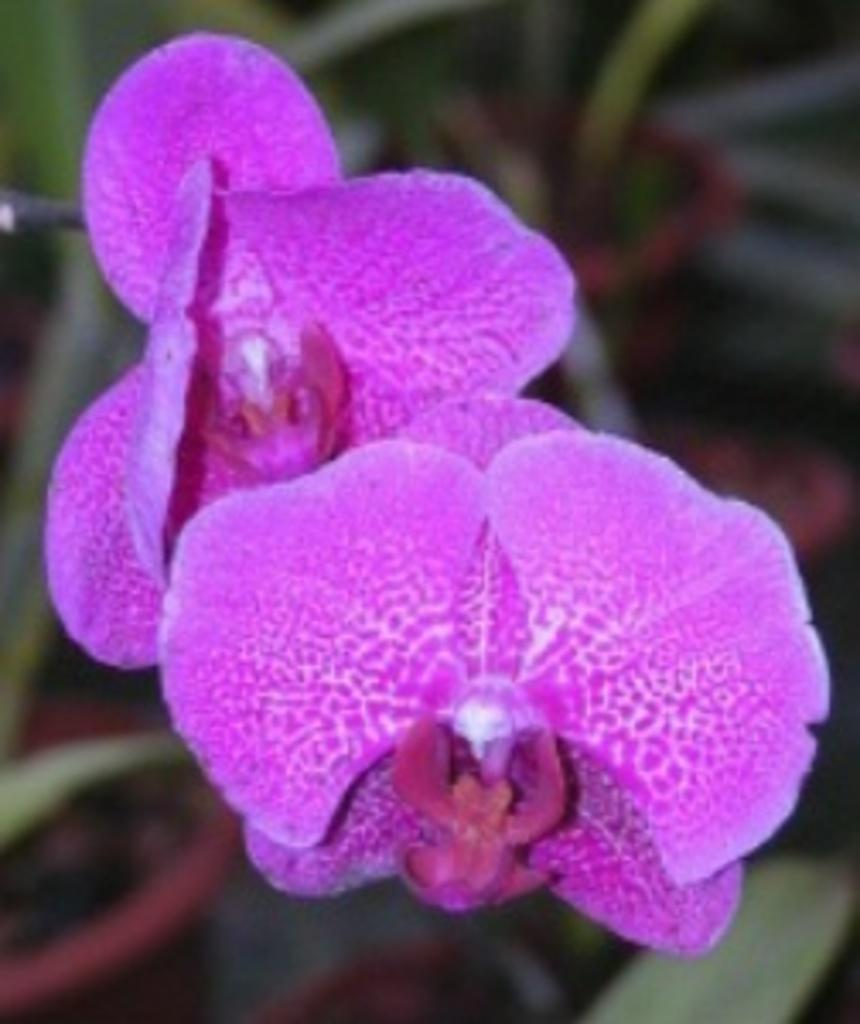What color are the leaves in the image? The leaves in the image are purple. Can you describe the background of the image? The background of the image is blurred. What type of attack is being carried out by the flame in the image? There is no flame or attack present in the image; it features purple leaves and a blurred background. 